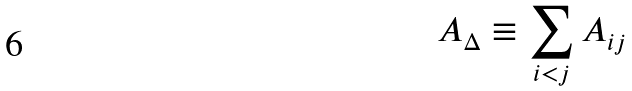Convert formula to latex. <formula><loc_0><loc_0><loc_500><loc_500>A _ { \Delta } \equiv \sum _ { i < j } A _ { i j }</formula> 